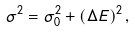<formula> <loc_0><loc_0><loc_500><loc_500>\sigma ^ { 2 } = \sigma _ { 0 } ^ { 2 } + ( \Delta E ) ^ { 2 } \, ,</formula> 